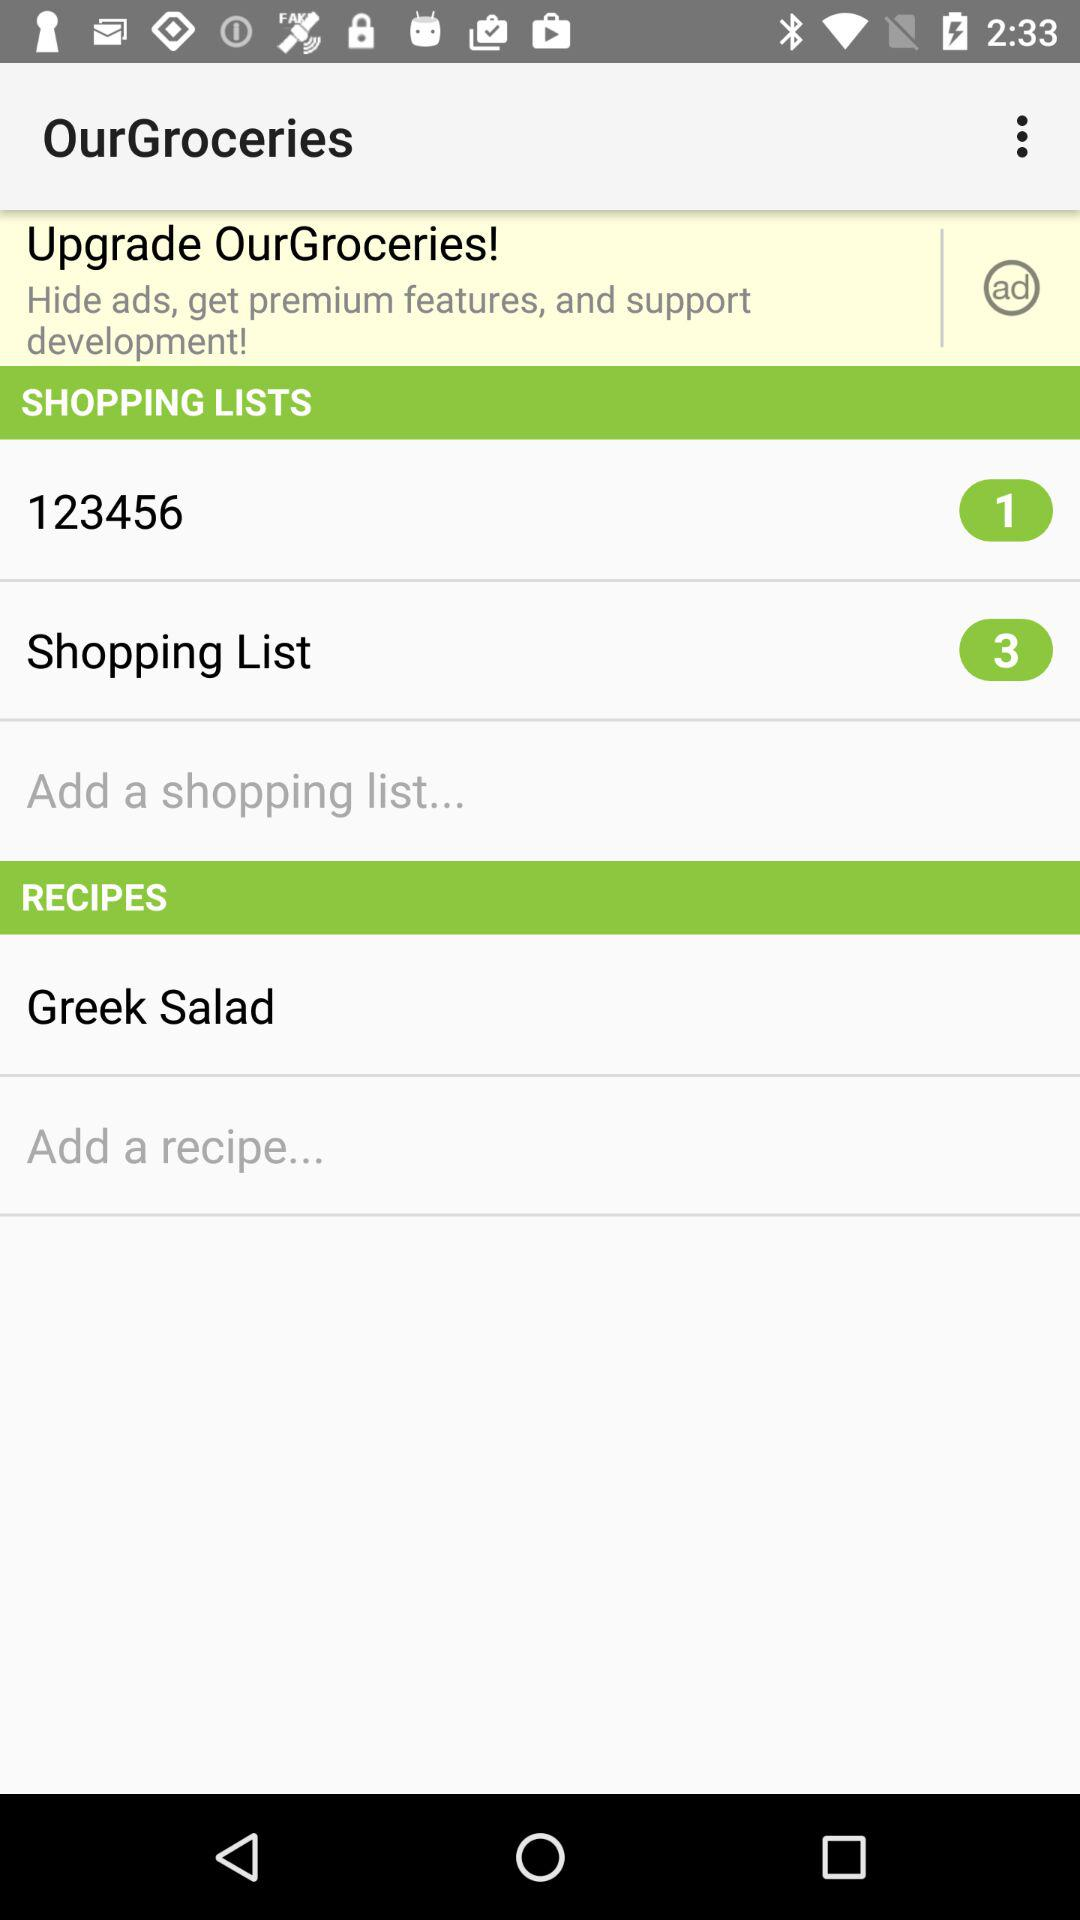What is the name of the added recipe? The name of the added recipe is "Greek Salad". 